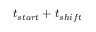Convert formula to latex. <formula><loc_0><loc_0><loc_500><loc_500>t _ { s t a r t } + t _ { s h i f t }</formula> 